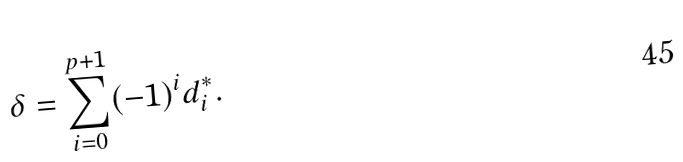<formula> <loc_0><loc_0><loc_500><loc_500>\delta = \sum _ { i = 0 } ^ { p + 1 } ( - 1 ) ^ { i } d _ { i } ^ { * } .</formula> 